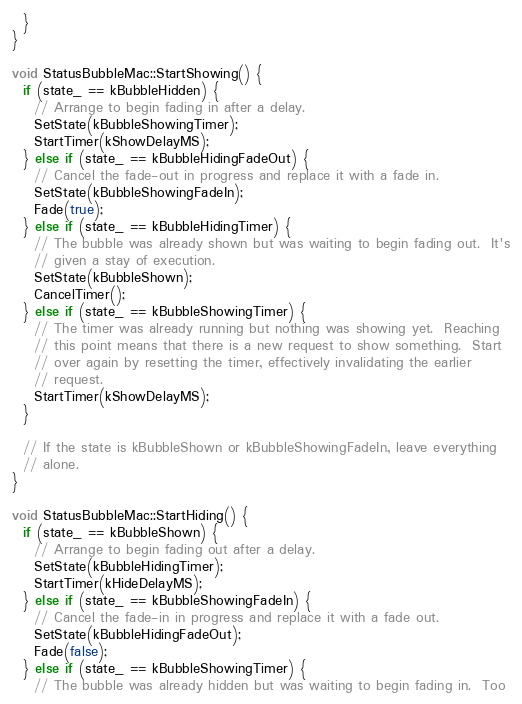<code> <loc_0><loc_0><loc_500><loc_500><_ObjectiveC_>  }
}

void StatusBubbleMac::StartShowing() {
  if (state_ == kBubbleHidden) {
    // Arrange to begin fading in after a delay.
    SetState(kBubbleShowingTimer);
    StartTimer(kShowDelayMS);
  } else if (state_ == kBubbleHidingFadeOut) {
    // Cancel the fade-out in progress and replace it with a fade in.
    SetState(kBubbleShowingFadeIn);
    Fade(true);
  } else if (state_ == kBubbleHidingTimer) {
    // The bubble was already shown but was waiting to begin fading out.  It's
    // given a stay of execution.
    SetState(kBubbleShown);
    CancelTimer();
  } else if (state_ == kBubbleShowingTimer) {
    // The timer was already running but nothing was showing yet.  Reaching
    // this point means that there is a new request to show something.  Start
    // over again by resetting the timer, effectively invalidating the earlier
    // request.
    StartTimer(kShowDelayMS);
  }

  // If the state is kBubbleShown or kBubbleShowingFadeIn, leave everything
  // alone.
}

void StatusBubbleMac::StartHiding() {
  if (state_ == kBubbleShown) {
    // Arrange to begin fading out after a delay.
    SetState(kBubbleHidingTimer);
    StartTimer(kHideDelayMS);
  } else if (state_ == kBubbleShowingFadeIn) {
    // Cancel the fade-in in progress and replace it with a fade out.
    SetState(kBubbleHidingFadeOut);
    Fade(false);
  } else if (state_ == kBubbleShowingTimer) {
    // The bubble was already hidden but was waiting to begin fading in.  Too</code> 